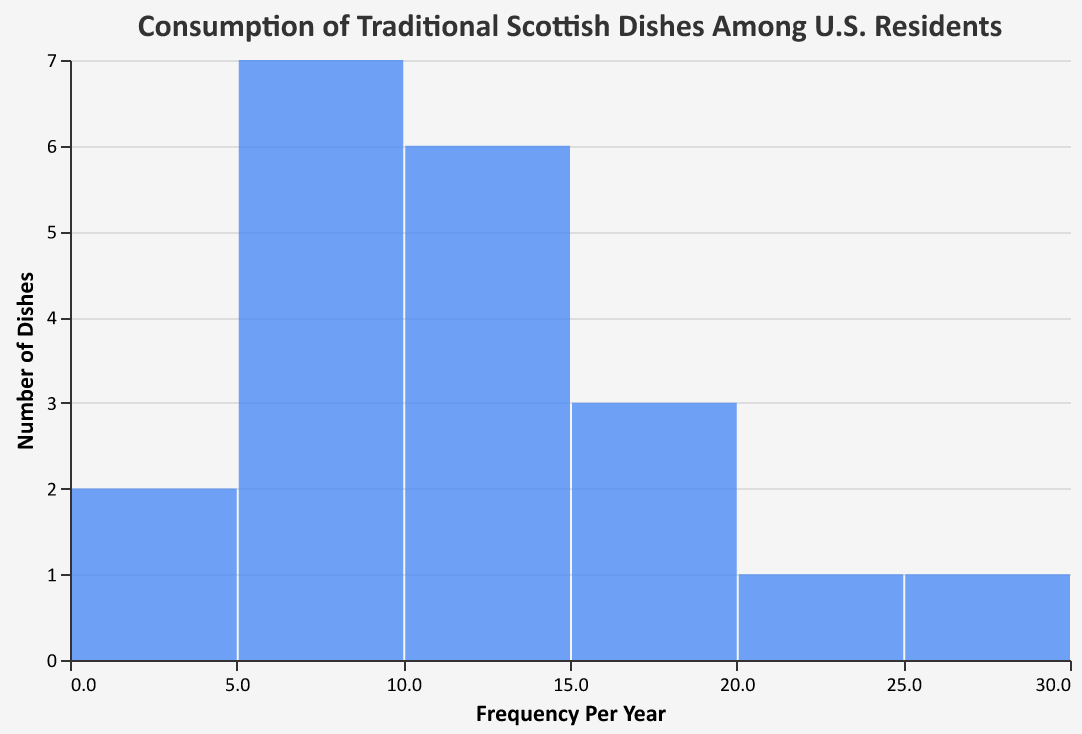What is the title of the figure? The title of the figure is typically located at the top and provides a summary of what the figure is about.
Answer: Consumption of Traditional Scottish Dishes Among U.S. Residents How many dishes are consumed between 10 and 19 times per year? To answer this, look at the bins on the x-axis that represent the range from 10 to 19, then count the corresponding bar heights, indicating the number of dishes in these bins.
Answer: 10 dishes Which dish has the highest frequency of consumption per year? Check the data or refer to the highest value in the figure. The tallest bar or the data with the maximum frequency will indicate the most frequently consumed dish.
Answer: Shortbread What is the range of frequencies of consumption per year shown on the x-axis? Look at the minimum and maximum values labeled on the x-axis to determine the range.
Answer: 3 to 30 How many more dishes are consumed at least 10 times per year compared to those consumed less than 10 times per year? First, count the number of dishes in bins with values ≥10 and then count those with values <10. Subtract the latter from the former for the difference.
Answer: 12 more dishes Which two frequency intervals have the same number of dishes, and what is that number? Identify the intervals by looking at the x-axis bins and compare the heights of the bars to find where they are equal, then check the y-axis to find the count.
Answer: 5-8 and 19-22, with 3 dishes each How many dishes are consumed exactly 5 times per year? Look for the specific frequency or bin size on the x-axis that represents "5" and read the height of that bar.
Answer: 2 dishes What is the median frequency of consumption per year? Arrange all the frequencies in ascending order and find the middle value. With 20 data points, the median is the average of the 10th and 11th values.
Answer: 10.5 times Which interval contains the outliers, if any? Outliers are typically identified by extremely low or high frequencies far from the rest of the data set. Check for bins with unusually high bars.
Answer: 29-32 interval What is the average frequency of consumption for the dishes? Sum all the dish frequencies and divide by the number of dishes (20) to get the average.
Answer: 11.75 times 